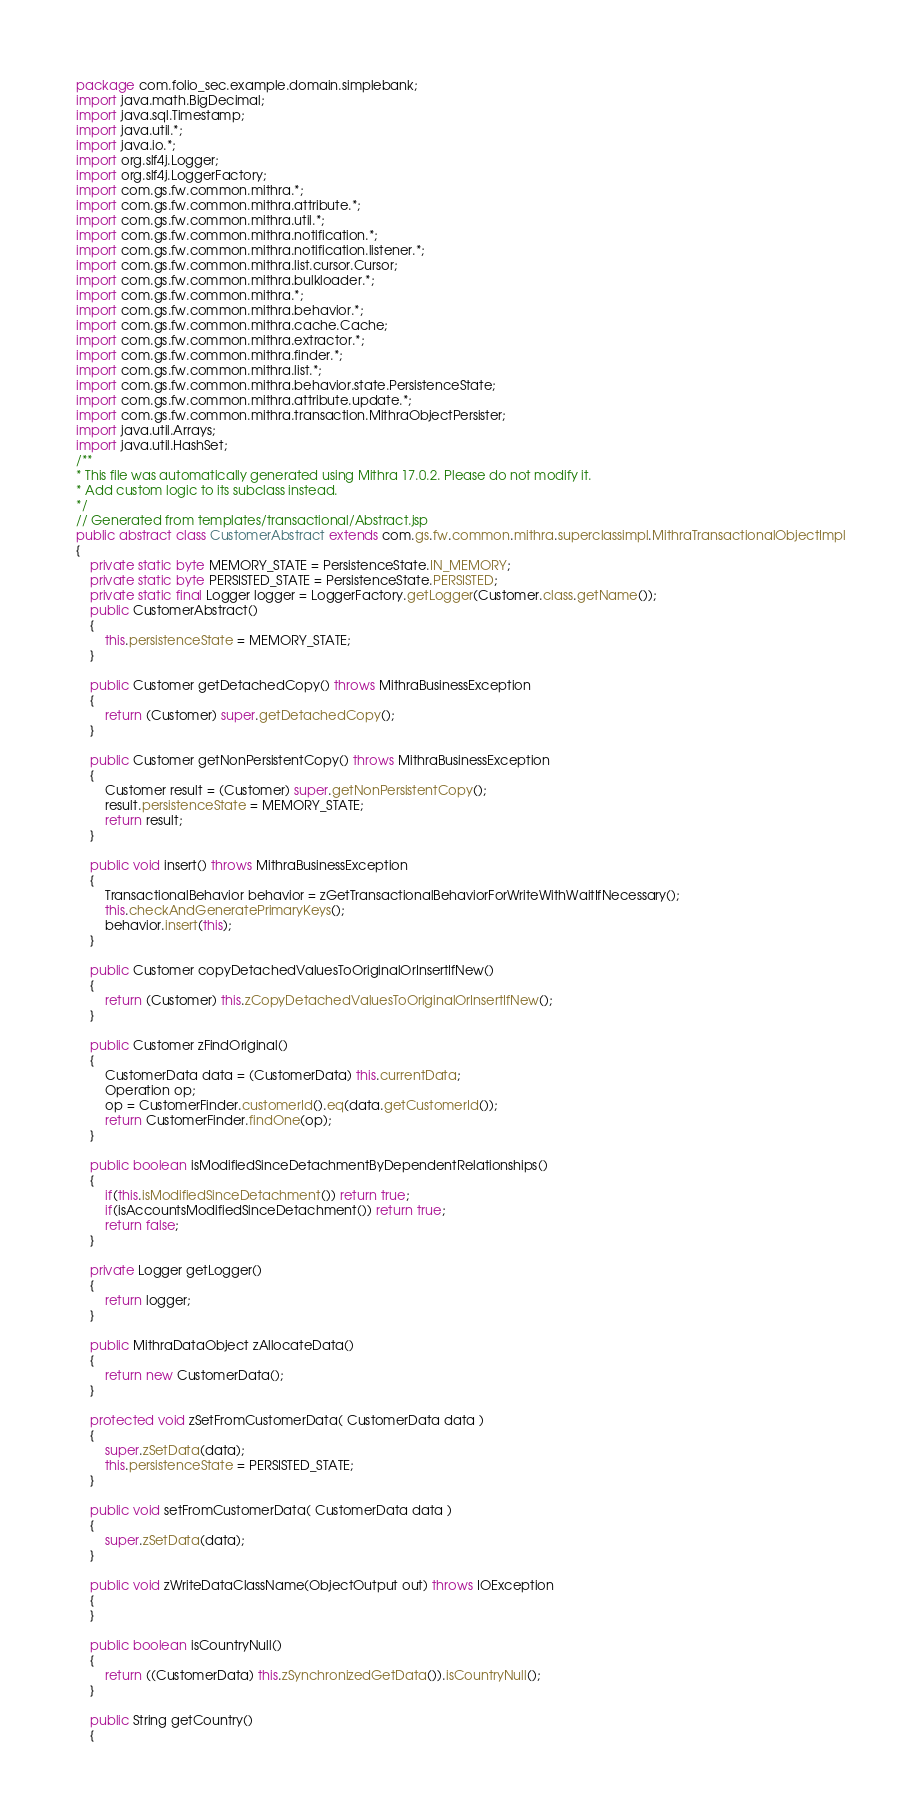Convert code to text. <code><loc_0><loc_0><loc_500><loc_500><_Java_>package com.folio_sec.example.domain.simplebank;
import java.math.BigDecimal;
import java.sql.Timestamp;
import java.util.*;
import java.io.*;
import org.slf4j.Logger;
import org.slf4j.LoggerFactory;
import com.gs.fw.common.mithra.*;
import com.gs.fw.common.mithra.attribute.*;
import com.gs.fw.common.mithra.util.*;
import com.gs.fw.common.mithra.notification.*;
import com.gs.fw.common.mithra.notification.listener.*;
import com.gs.fw.common.mithra.list.cursor.Cursor;
import com.gs.fw.common.mithra.bulkloader.*;
import com.gs.fw.common.mithra.*;
import com.gs.fw.common.mithra.behavior.*;
import com.gs.fw.common.mithra.cache.Cache;
import com.gs.fw.common.mithra.extractor.*;
import com.gs.fw.common.mithra.finder.*;
import com.gs.fw.common.mithra.list.*;
import com.gs.fw.common.mithra.behavior.state.PersistenceState;
import com.gs.fw.common.mithra.attribute.update.*;
import com.gs.fw.common.mithra.transaction.MithraObjectPersister;
import java.util.Arrays;
import java.util.HashSet;
/**
* This file was automatically generated using Mithra 17.0.2. Please do not modify it.
* Add custom logic to its subclass instead.
*/
// Generated from templates/transactional/Abstract.jsp
public abstract class CustomerAbstract extends com.gs.fw.common.mithra.superclassimpl.MithraTransactionalObjectImpl
{
	private static byte MEMORY_STATE = PersistenceState.IN_MEMORY;
	private static byte PERSISTED_STATE = PersistenceState.PERSISTED;
	private static final Logger logger = LoggerFactory.getLogger(Customer.class.getName());
	public CustomerAbstract()
	{
		this.persistenceState = MEMORY_STATE;
	}

	public Customer getDetachedCopy() throws MithraBusinessException
	{
		return (Customer) super.getDetachedCopy();
	}

	public Customer getNonPersistentCopy() throws MithraBusinessException
	{
		Customer result = (Customer) super.getNonPersistentCopy();
		result.persistenceState = MEMORY_STATE;
		return result;
	}

	public void insert() throws MithraBusinessException
	{
		TransactionalBehavior behavior = zGetTransactionalBehaviorForWriteWithWaitIfNecessary();
		this.checkAndGeneratePrimaryKeys();
		behavior.insert(this);
	}

	public Customer copyDetachedValuesToOriginalOrInsertIfNew()
	{
		return (Customer) this.zCopyDetachedValuesToOriginalOrInsertIfNew();
	}

	public Customer zFindOriginal()
	{
		CustomerData data = (CustomerData) this.currentData;
		Operation op;
		op = CustomerFinder.customerId().eq(data.getCustomerId());
		return CustomerFinder.findOne(op);
	}

	public boolean isModifiedSinceDetachmentByDependentRelationships()
	{
		if(this.isModifiedSinceDetachment()) return true;
		if(isAccountsModifiedSinceDetachment()) return true;
		return false;
	}

	private Logger getLogger()
	{
		return logger;
	}

	public MithraDataObject zAllocateData()
	{
		return new CustomerData();
	}

	protected void zSetFromCustomerData( CustomerData data )
	{
		super.zSetData(data);
		this.persistenceState = PERSISTED_STATE;
	}

	public void setFromCustomerData( CustomerData data )
	{
		super.zSetData(data);
	}

	public void zWriteDataClassName(ObjectOutput out) throws IOException
	{
	}

	public boolean isCountryNull()
	{
		return ((CustomerData) this.zSynchronizedGetData()).isCountryNull();
	}

	public String getCountry()
	{</code> 